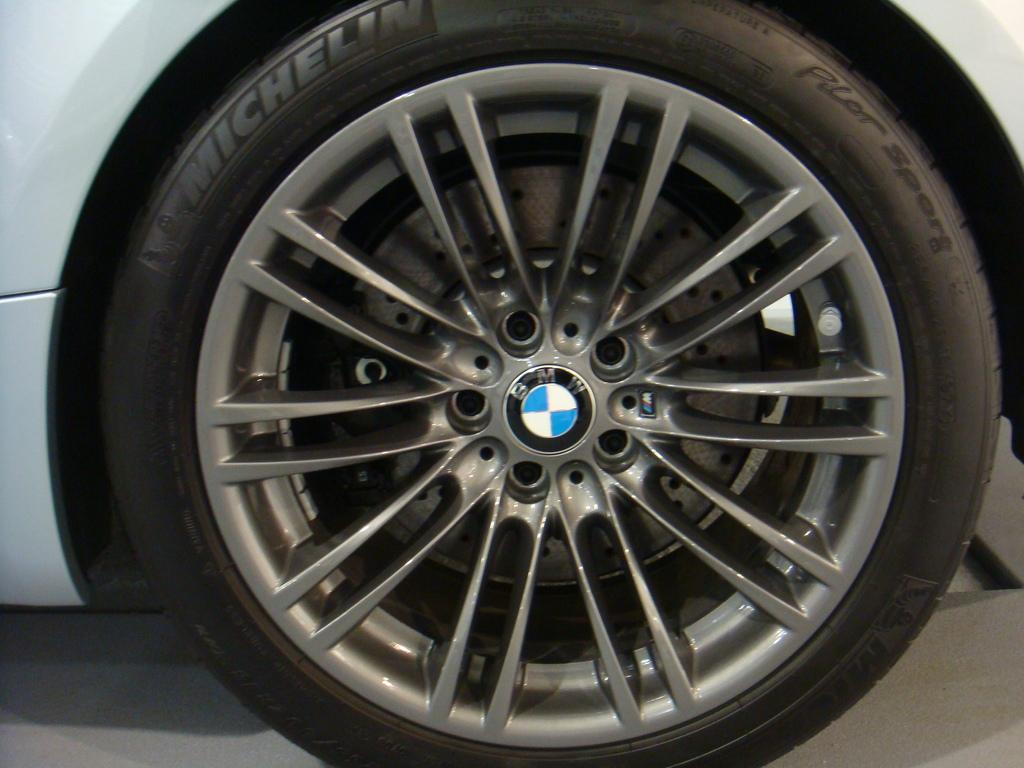What is the main subject of the image? The main subject of the image is a car wheel. Are there any markings or text on the car wheel? Yes, there is text on the tire. What can be seen in the center of the image? There is a logo and text in the center of the image. What is visible at the bottom of the image? The floor is visible at the bottom of the image. How many eggs are being carried by the coach in the image? There is no coach or eggs present in the image; it features a car wheel with text and a logo. 